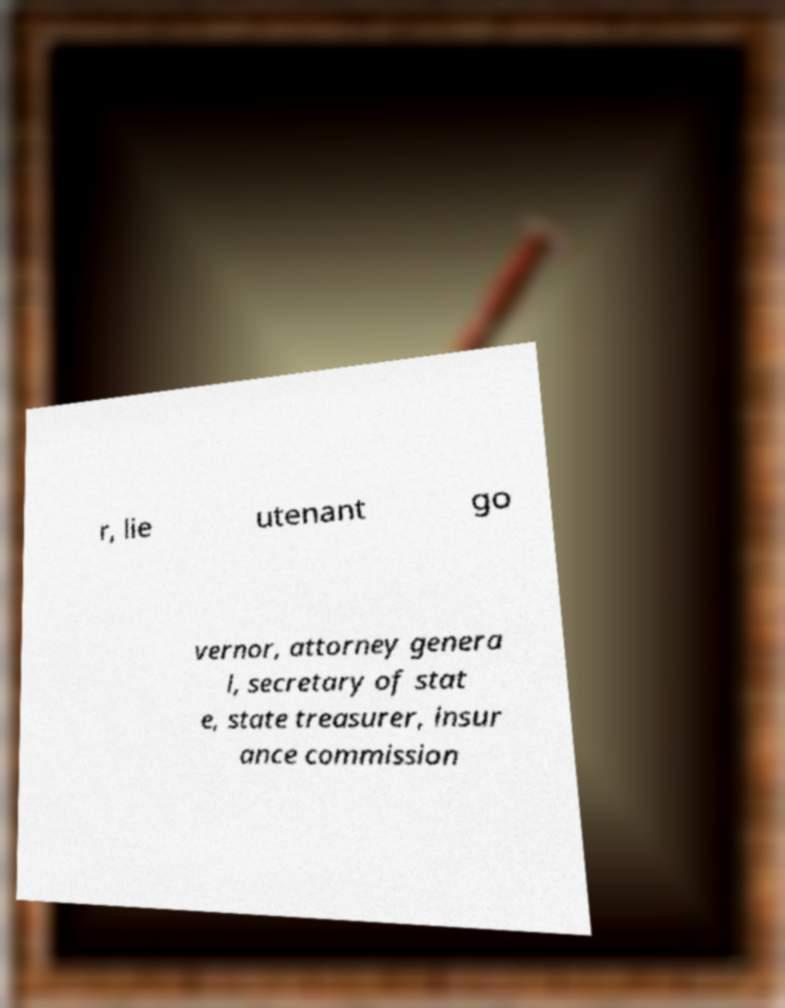For documentation purposes, I need the text within this image transcribed. Could you provide that? r, lie utenant go vernor, attorney genera l, secretary of stat e, state treasurer, insur ance commission 